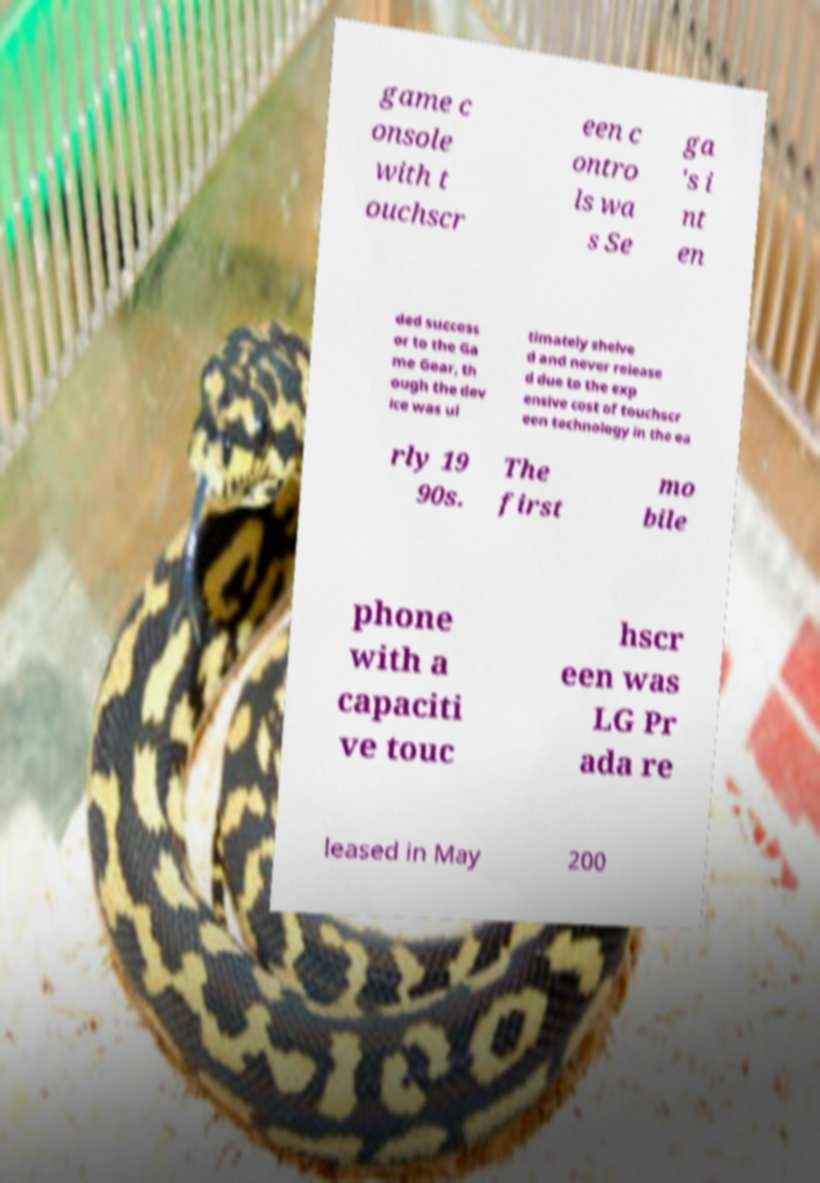Could you assist in decoding the text presented in this image and type it out clearly? game c onsole with t ouchscr een c ontro ls wa s Se ga 's i nt en ded success or to the Ga me Gear, th ough the dev ice was ul timately shelve d and never release d due to the exp ensive cost of touchscr een technology in the ea rly 19 90s. The first mo bile phone with a capaciti ve touc hscr een was LG Pr ada re leased in May 200 